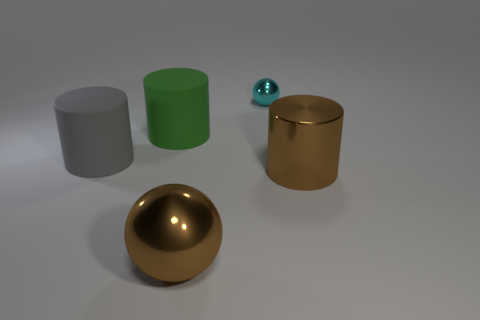Subtract all matte cylinders. How many cylinders are left? 1 Subtract all green cylinders. How many cylinders are left? 2 Subtract 0 cyan cylinders. How many objects are left? 5 Subtract all cylinders. How many objects are left? 2 Subtract 1 cylinders. How many cylinders are left? 2 Subtract all gray spheres. Subtract all gray cubes. How many spheres are left? 2 Subtract all yellow spheres. How many green cylinders are left? 1 Subtract all small purple cylinders. Subtract all big metallic cylinders. How many objects are left? 4 Add 2 large metallic cylinders. How many large metallic cylinders are left? 3 Add 1 big gray rubber cylinders. How many big gray rubber cylinders exist? 2 